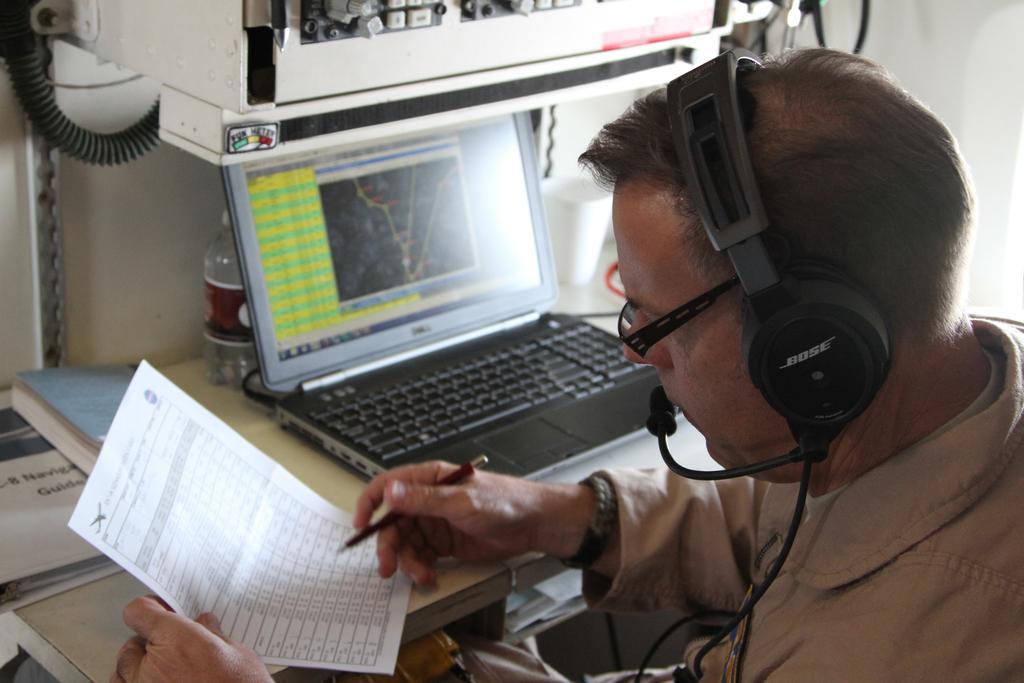In one or two sentences, can you explain what this image depicts? In the picture we can see a man sitting near the table holding a pen and a paper and he is wearing a headset and in front of him we can see the desk with a laptop on it which is opened and on the top of it we can see some machinery object and beside the laptop we can see a water bottle and a book. 